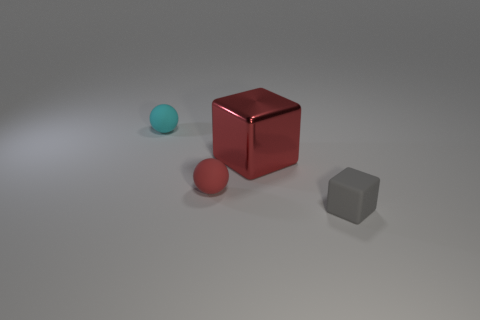What is the size of the object that is left of the red shiny thing and behind the red rubber ball?
Keep it short and to the point. Small. What color is the thing that is behind the small red thing and to the left of the metallic thing?
Ensure brevity in your answer.  Cyan. Are there fewer red matte balls that are to the right of the red metallic block than shiny cubes that are on the left side of the small red rubber thing?
Provide a short and direct response. No. What number of big shiny objects are the same shape as the tiny red matte thing?
Offer a very short reply. 0. There is a cyan ball that is the same material as the gray thing; what size is it?
Offer a very short reply. Small. There is a small matte object that is to the right of the small red sphere that is in front of the red shiny object; what is its color?
Keep it short and to the point. Gray. Does the small red rubber thing have the same shape as the object that is in front of the tiny red thing?
Your response must be concise. No. What number of gray things have the same size as the cyan rubber object?
Provide a short and direct response. 1. There is another object that is the same shape as the cyan matte thing; what is it made of?
Your response must be concise. Rubber. Do the rubber thing in front of the red matte thing and the tiny sphere in front of the metal block have the same color?
Provide a short and direct response. No. 